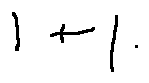Convert formula to latex. <formula><loc_0><loc_0><loc_500><loc_500>1 + 1</formula> 